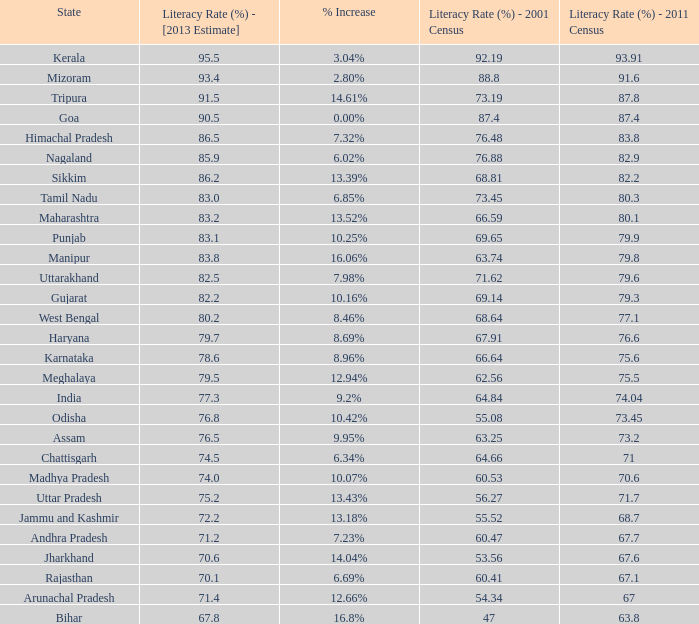What is the average estimated 2013 literacy rate for the states that had a literacy rate of 68.81% in the 2001 census and a literacy rate higher than 79.6% in the 2011 census? 86.2. 